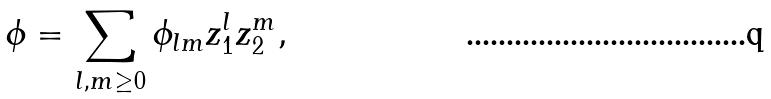<formula> <loc_0><loc_0><loc_500><loc_500>\phi = \sum _ { l , m \geq 0 } \phi _ { l m } z _ { 1 } ^ { l } z _ { 2 } ^ { m } ,</formula> 